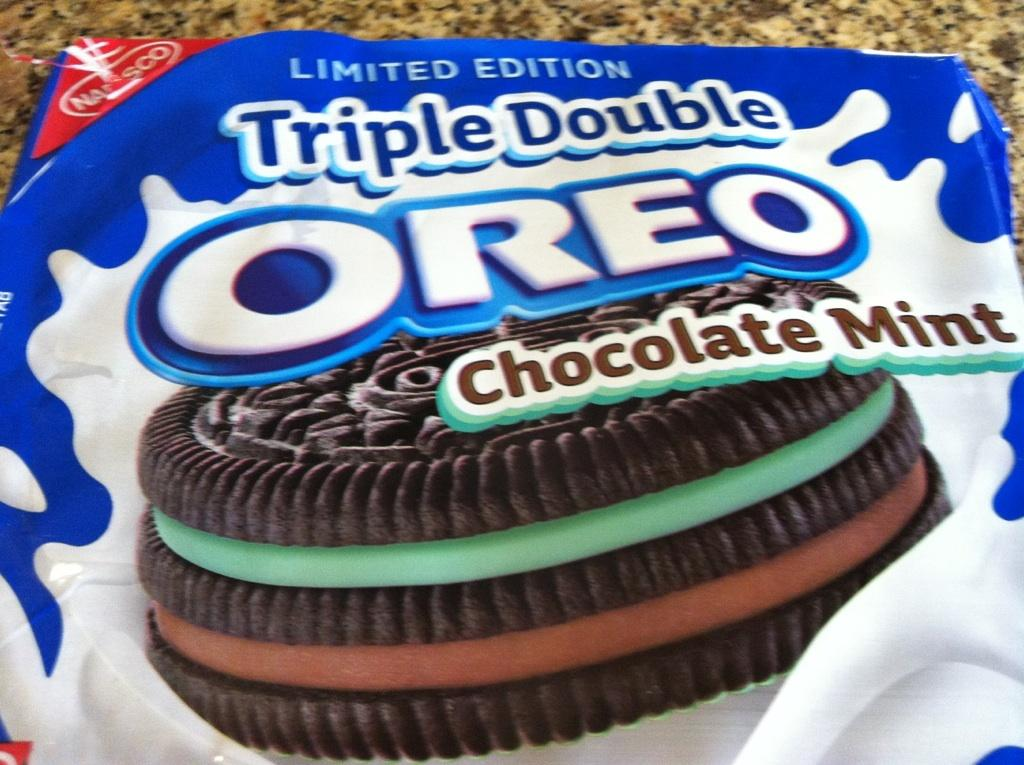What is on the floor in the image? There is a pack of biscuits on the floor in the image. What type of rose can be seen growing near the biscuits in the image? There is no rose present in the image; it only features a pack of biscuits on the floor. 